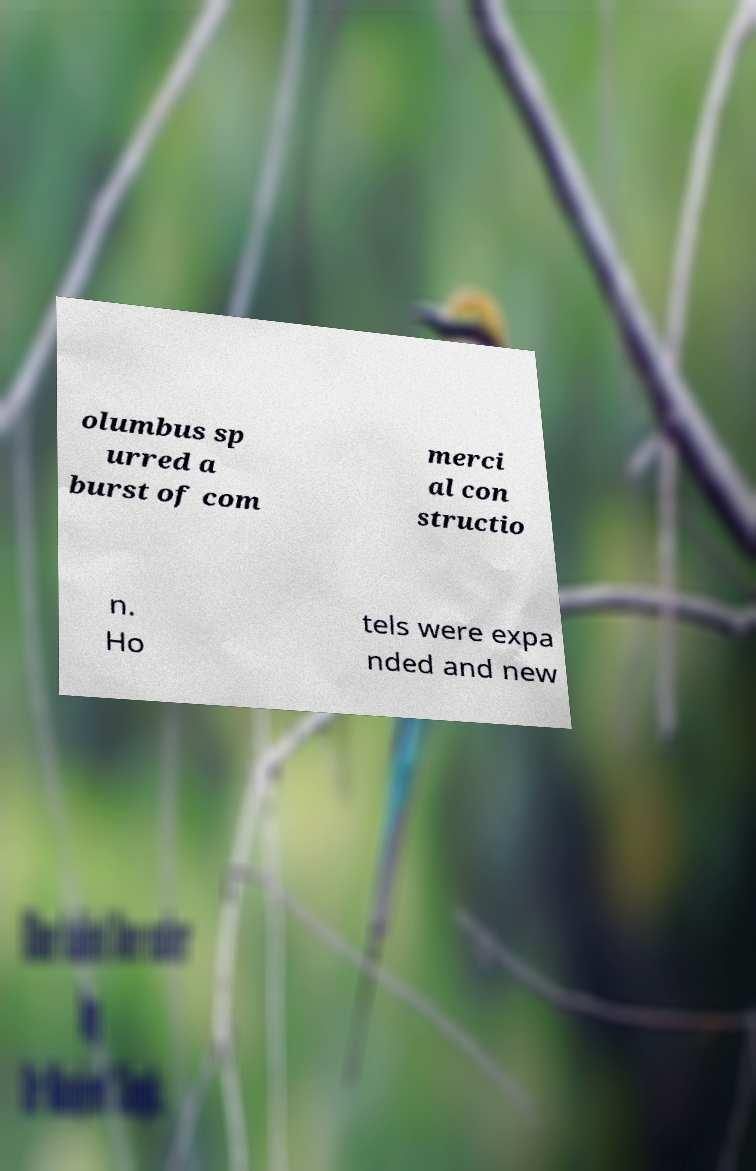Could you assist in decoding the text presented in this image and type it out clearly? olumbus sp urred a burst of com merci al con structio n. Ho tels were expa nded and new 